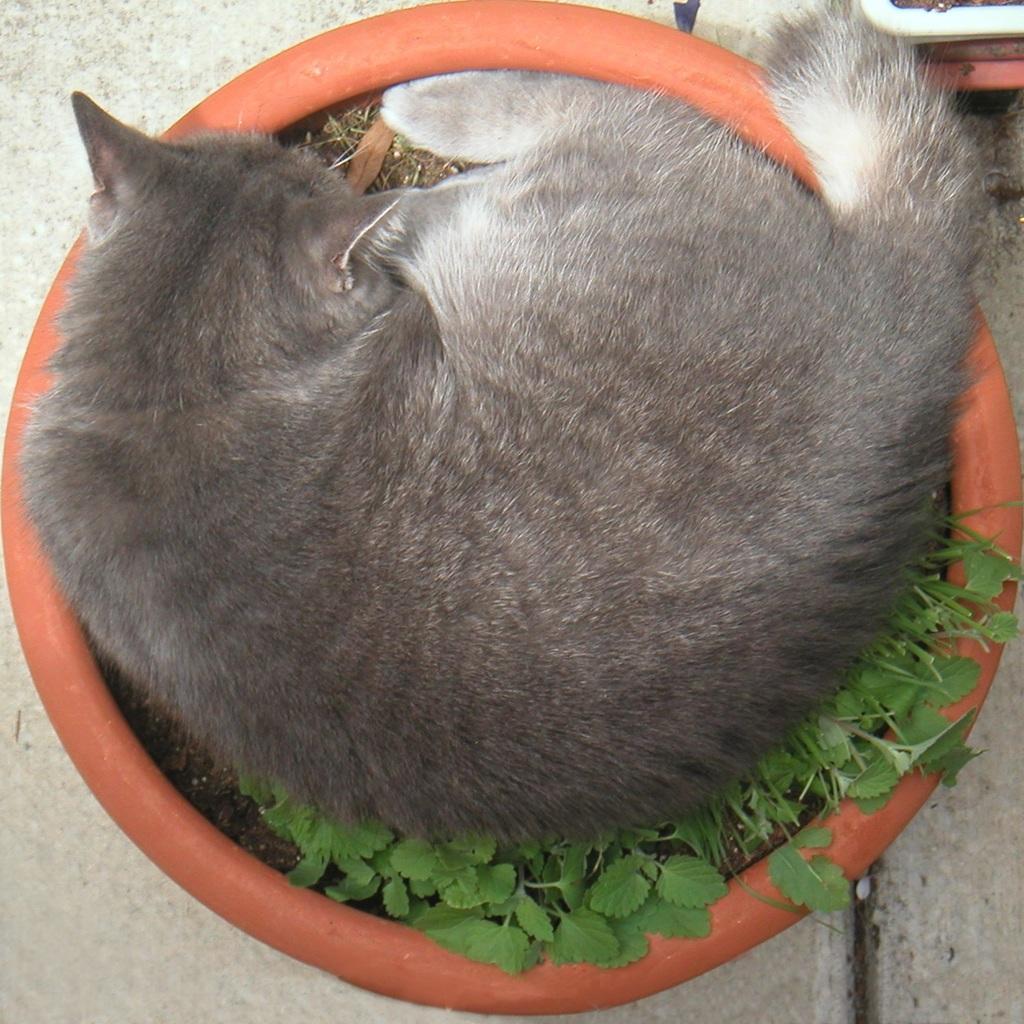In one or two sentences, can you explain what this image depicts? In this image I can see cat sitting on the plant pot which is on the floor. 